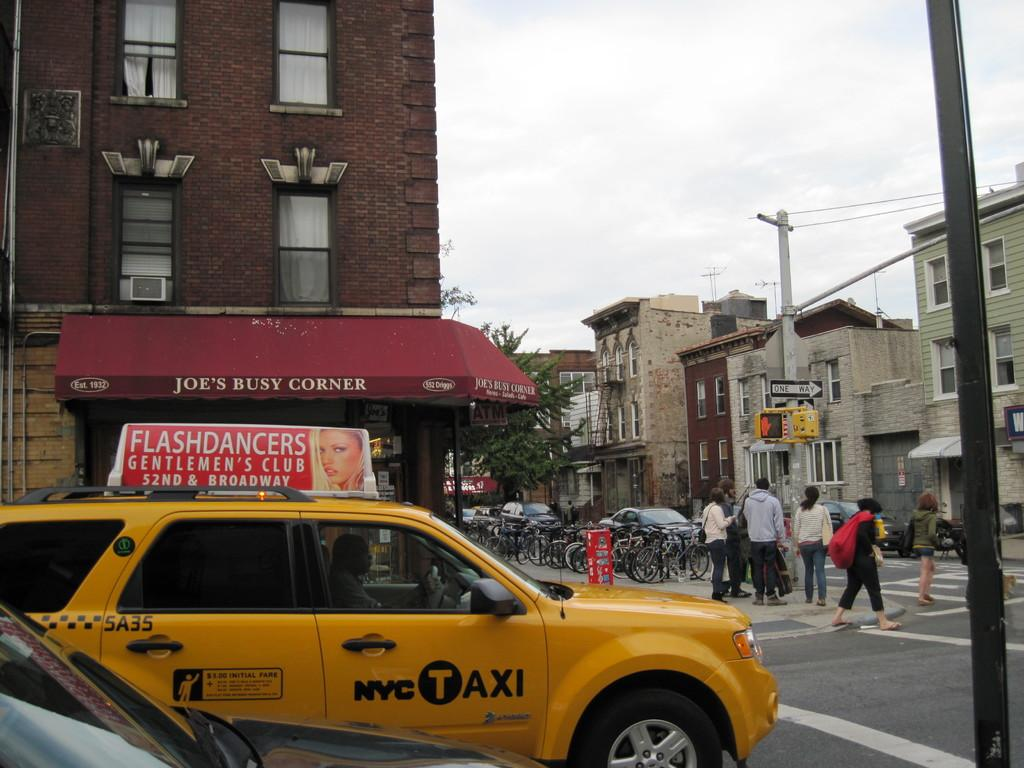What type of vehicle is at the bottom of the image? There is a yellow car at the bottom of the image. What are the people in the image doing? The people in the image are walking on the right side. What type of structures can be seen in the image? There are houses in the image. What part of the natural environment is visible in the image? The sky is visible in the middle of the image. Can you see any knives being used by the fairies in the image? There are no fairies or knives present in the image. What type of play is happening in the image? There is no play depicted in the image; it features a yellow car, people walking, houses, and the sky. 